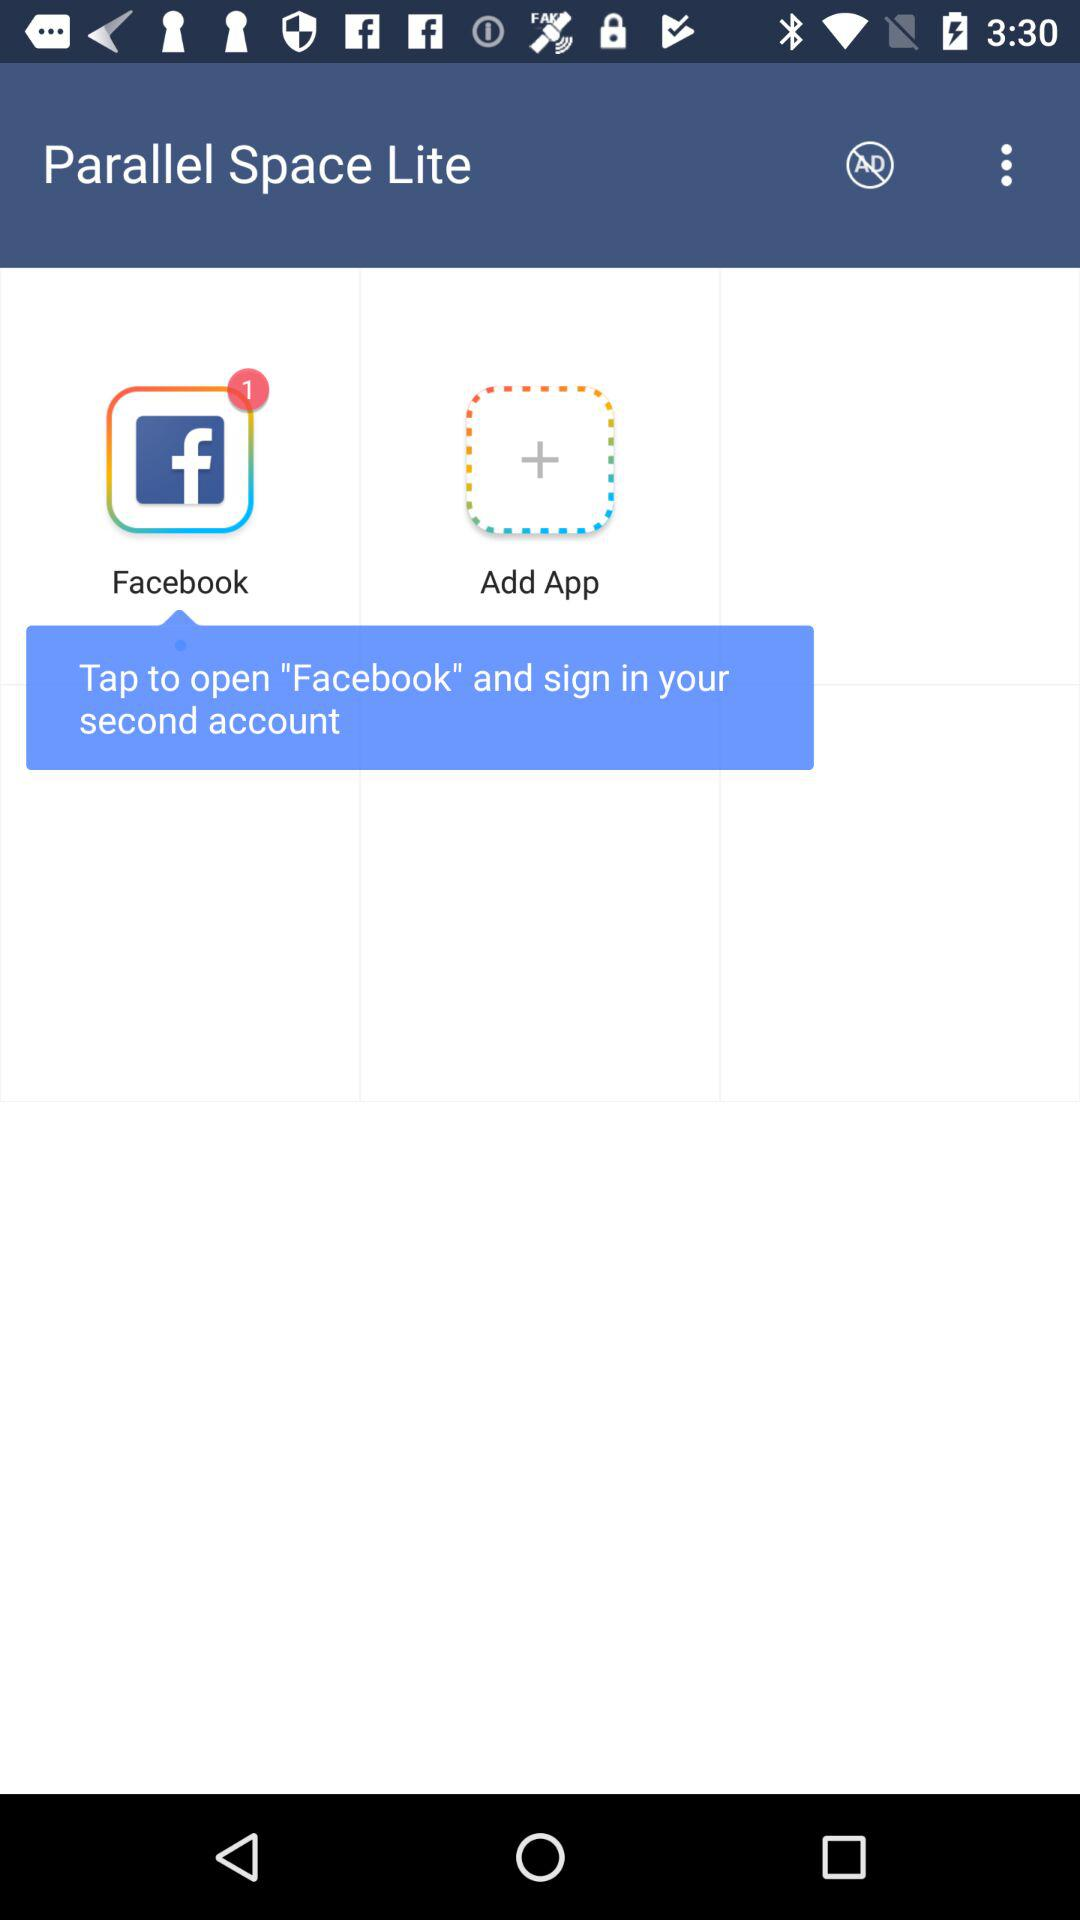Who is this application powered by?
When the provided information is insufficient, respond with <no answer>. <no answer> 